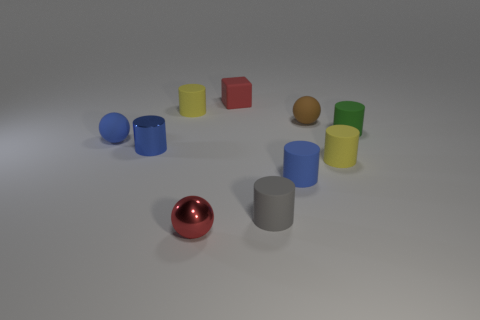There is a matte sphere that is left of the tiny red block; is its color the same as the small metal cylinder?
Make the answer very short. Yes. What is the shape of the tiny red thing behind the brown rubber thing?
Offer a terse response. Cube. What is the color of the rubber object right of the tiny yellow matte cylinder that is in front of the blue cylinder that is to the left of the red rubber cube?
Your answer should be very brief. Green. Is the material of the tiny green object the same as the red cube?
Give a very brief answer. Yes. What number of purple objects are balls or cubes?
Your answer should be compact. 0. There is a small brown rubber sphere; what number of blocks are behind it?
Your response must be concise. 1. Is the number of big red matte things greater than the number of tiny rubber cylinders?
Keep it short and to the point. No. There is a tiny red object behind the tiny blue thing that is behind the small metallic cylinder; what is its shape?
Offer a terse response. Cube. Is the metal ball the same color as the small rubber cube?
Give a very brief answer. Yes. Is the number of tiny blue metallic cylinders that are in front of the small gray object greater than the number of blue matte balls?
Your answer should be very brief. No. 